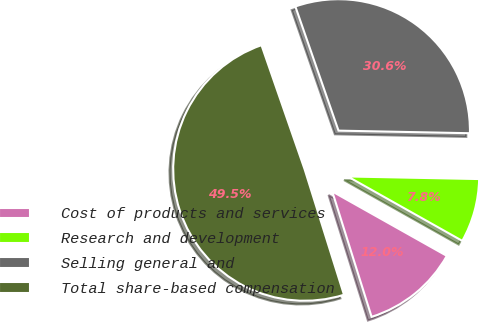Convert chart. <chart><loc_0><loc_0><loc_500><loc_500><pie_chart><fcel>Cost of products and services<fcel>Research and development<fcel>Selling general and<fcel>Total share-based compensation<nl><fcel>12.01%<fcel>7.84%<fcel>30.64%<fcel>49.52%<nl></chart> 